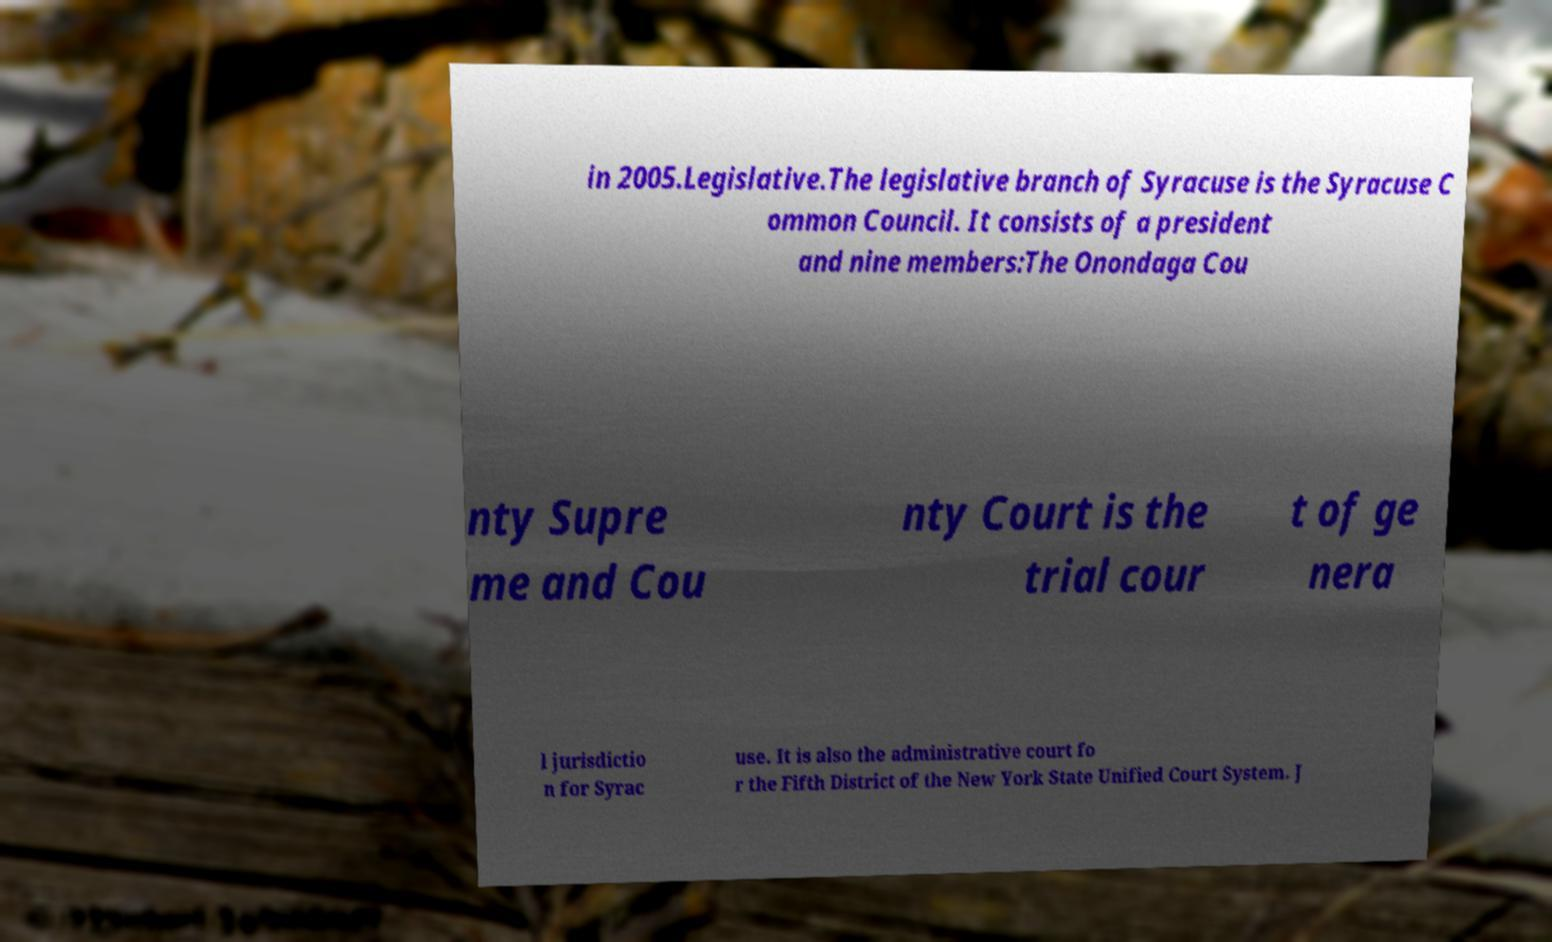I need the written content from this picture converted into text. Can you do that? in 2005.Legislative.The legislative branch of Syracuse is the Syracuse C ommon Council. It consists of a president and nine members:The Onondaga Cou nty Supre me and Cou nty Court is the trial cour t of ge nera l jurisdictio n for Syrac use. It is also the administrative court fo r the Fifth District of the New York State Unified Court System. J 